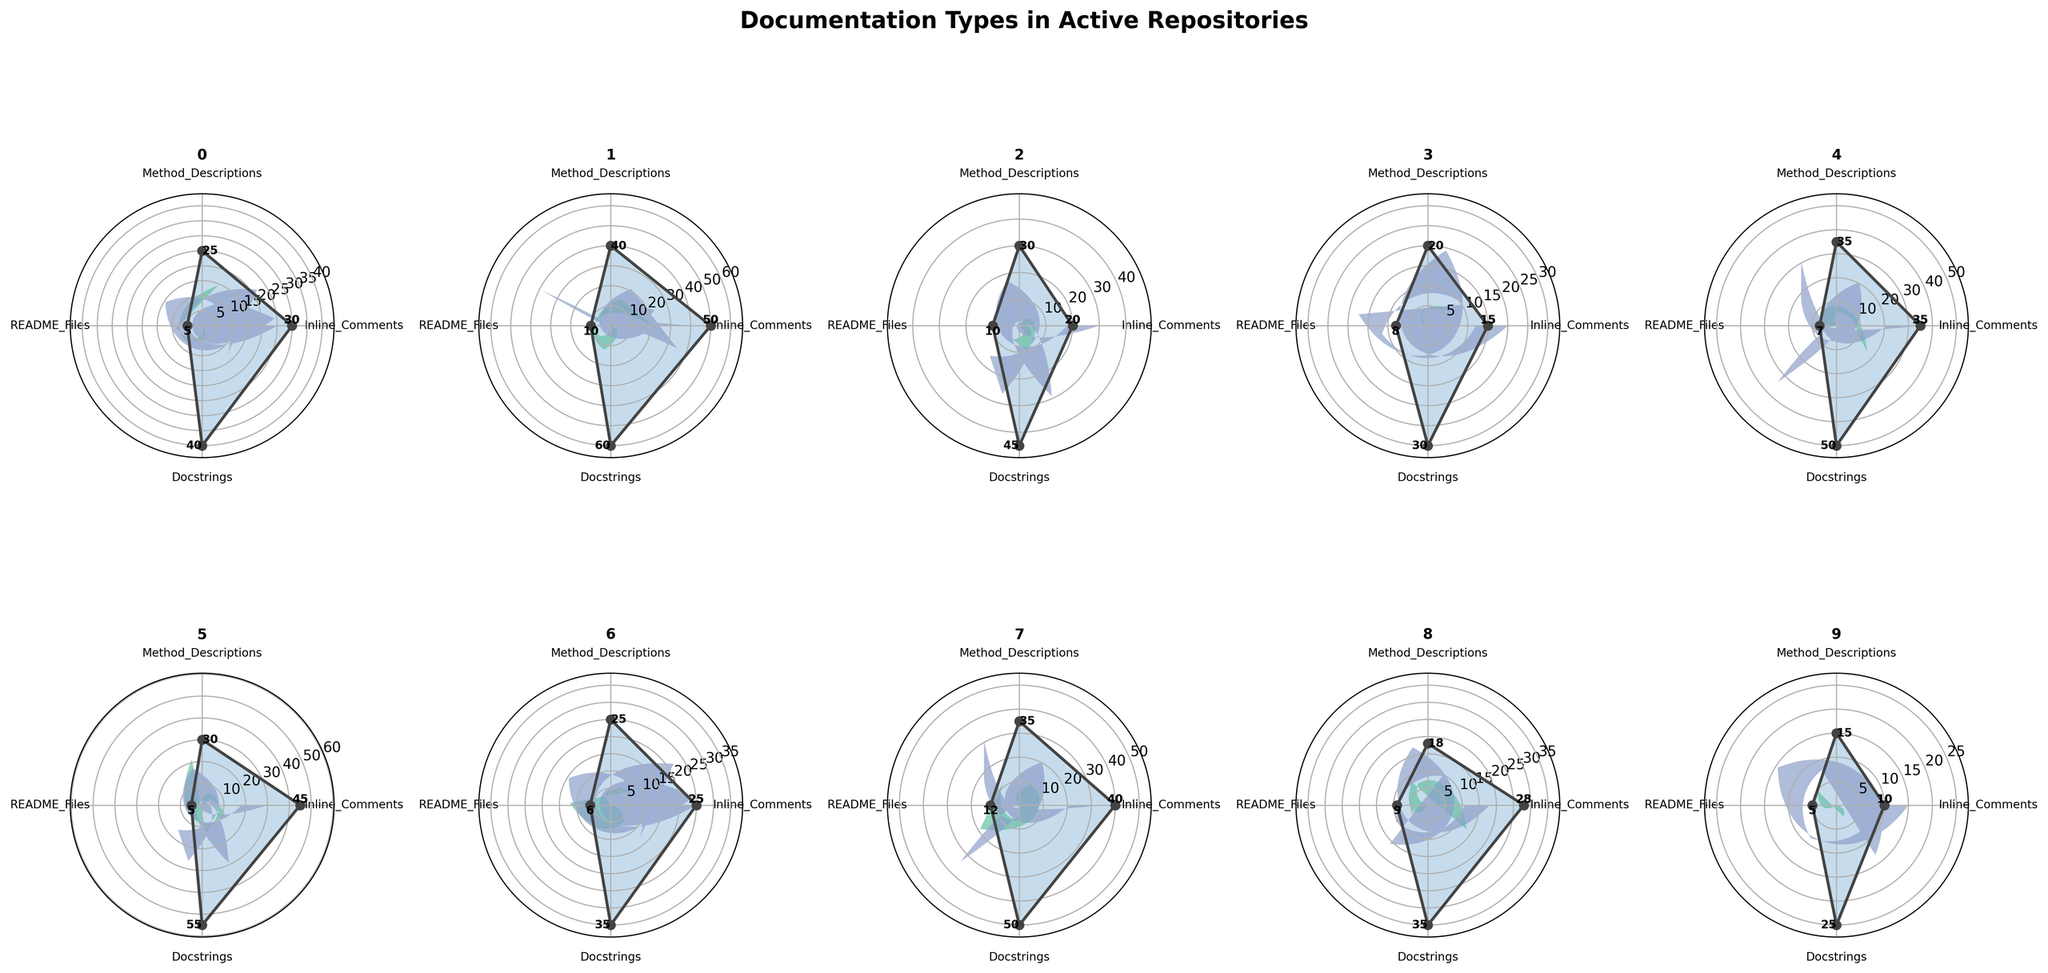How many repositories are included in the figure? All ten subplots represent a separate repository, and since there are 2 rows and 5 columns, the total number of repositories shown is 10
Answer: 10 What is the title of the figure? The title of the figure, located at the top of the whole set of subplots, is 'Documentation Types in Active Repositories'
Answer: Documentation Types in Active Repositories Which repository has the highest number of inline comments? By comparing all subplots, TensorFlow has the highest number of inline comments at 50, indicated by the length of the corresponding segment and the value label
Answer: TensorFlow Which has more method descriptions: Flask or FastAPI? By comparing the ‘Method Descriptions’ segments in both subplots, Flask has 20 while FastAPI has 15, so Flask has more
Answer: Flask Which repository has the smallest number of README files? By checking the segments for README files in each subplot, OpenCV, FastAPI, and NumPy all have the smallest value at 5
Answer: OpenCV, FastAPI, NumPy What is the sum of docstrings and inline comments for the Pandas repository? For Pandas, the values are 35 for inline comments and 50 for docstrings. The sum is 35 + 50 = 85
Answer: 85 In which repository are method descriptions and README files equal? By comparing each subplot's segments for method descriptions and README files, Django and Keras both have equal counts of 30 and 45 respectively
Answer: Django, Keras Which repository has the highest combined value for all documentation types? Adding up the values for each documentation type in each subplot, TensorFlow has the highest combined value (50 + 40 + 10 + 60 = 160)
Answer: TensorFlow Which category has the highest median value across all repositories? Collecting the values for each category: Inline Comments (10, 15, 20, 25, 28, 30, 35, 40, 45, 50), Method Descriptions (15, 18, 20, 25, 25, 30, 30, 35, 35, 40), README Files (5, 5, 5, 6, 7, 8, 9, 10, 12, 45), and Docstrings (25, 30, 35, 35, 40, 45, 50, 50, 55, 60). The median is Inline Comments (27.5), Method Descriptions (27.5), README Files (7.5), and Docstrings (42.5). Hence, Docstrings have the highest median value
Answer: Docstrings What is the ratio of docstrings to inline comments for the NumPy repository? NumPy’s plot has 55 docstrings and 45 inline comments. The ratio of docstrings to inline comments is 55/45, which simplifies to about 1.22
Answer: 1.22 